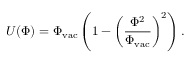<formula> <loc_0><loc_0><loc_500><loc_500>U ( \Phi ) = \Phi _ { v a c } \left ( 1 - \left ( \frac { \Phi ^ { 2 } } { \Phi _ { v a c } } \right ) ^ { 2 } \right ) .</formula> 